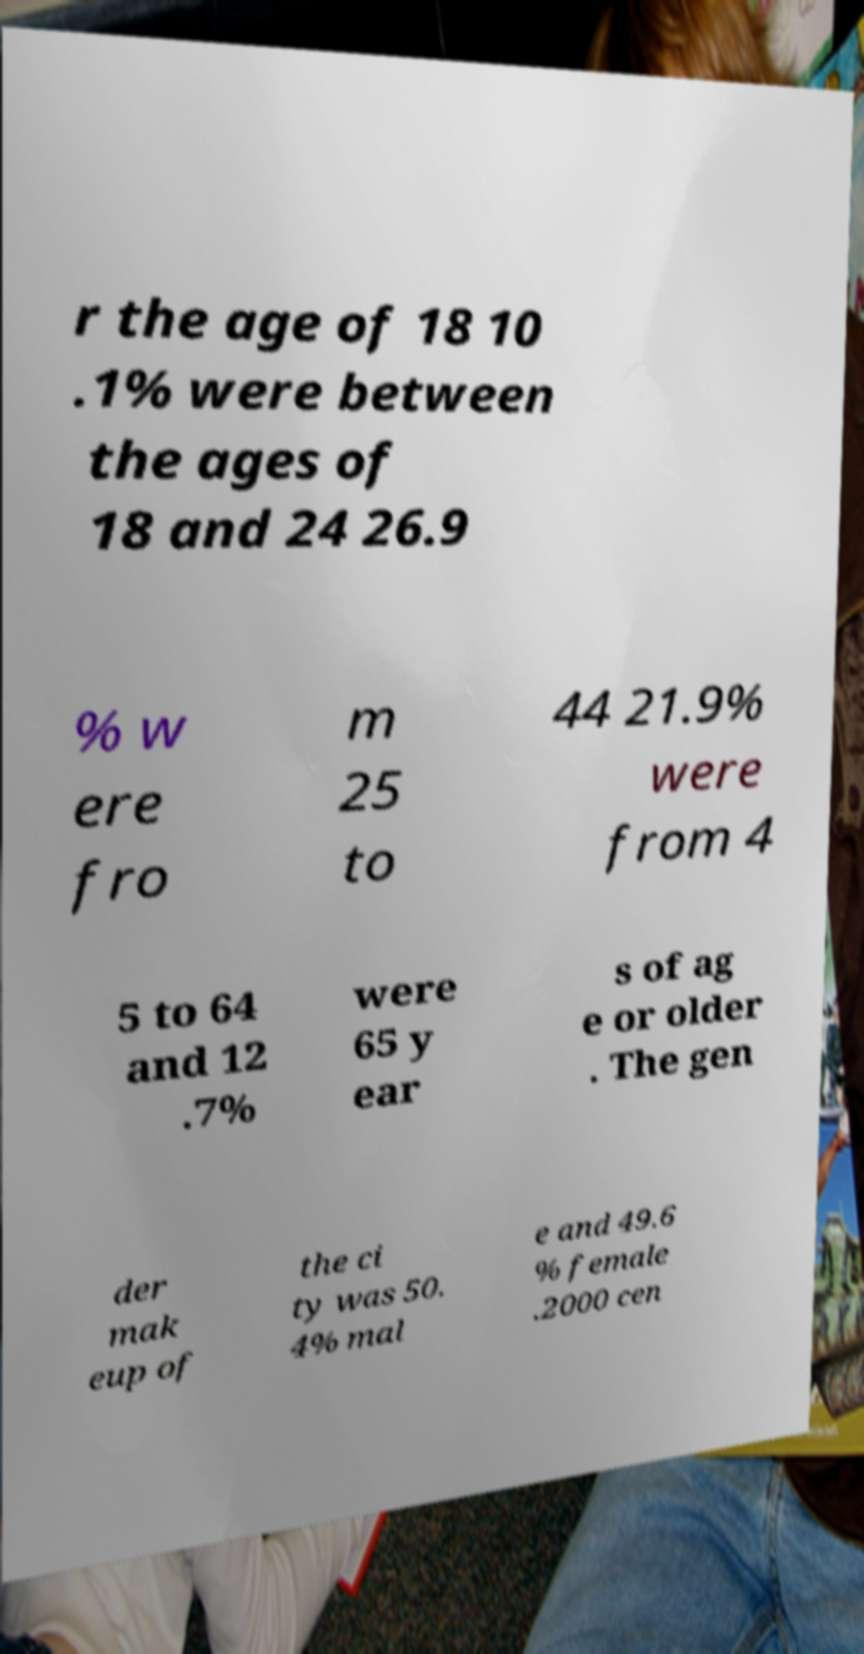For documentation purposes, I need the text within this image transcribed. Could you provide that? r the age of 18 10 .1% were between the ages of 18 and 24 26.9 % w ere fro m 25 to 44 21.9% were from 4 5 to 64 and 12 .7% were 65 y ear s of ag e or older . The gen der mak eup of the ci ty was 50. 4% mal e and 49.6 % female .2000 cen 